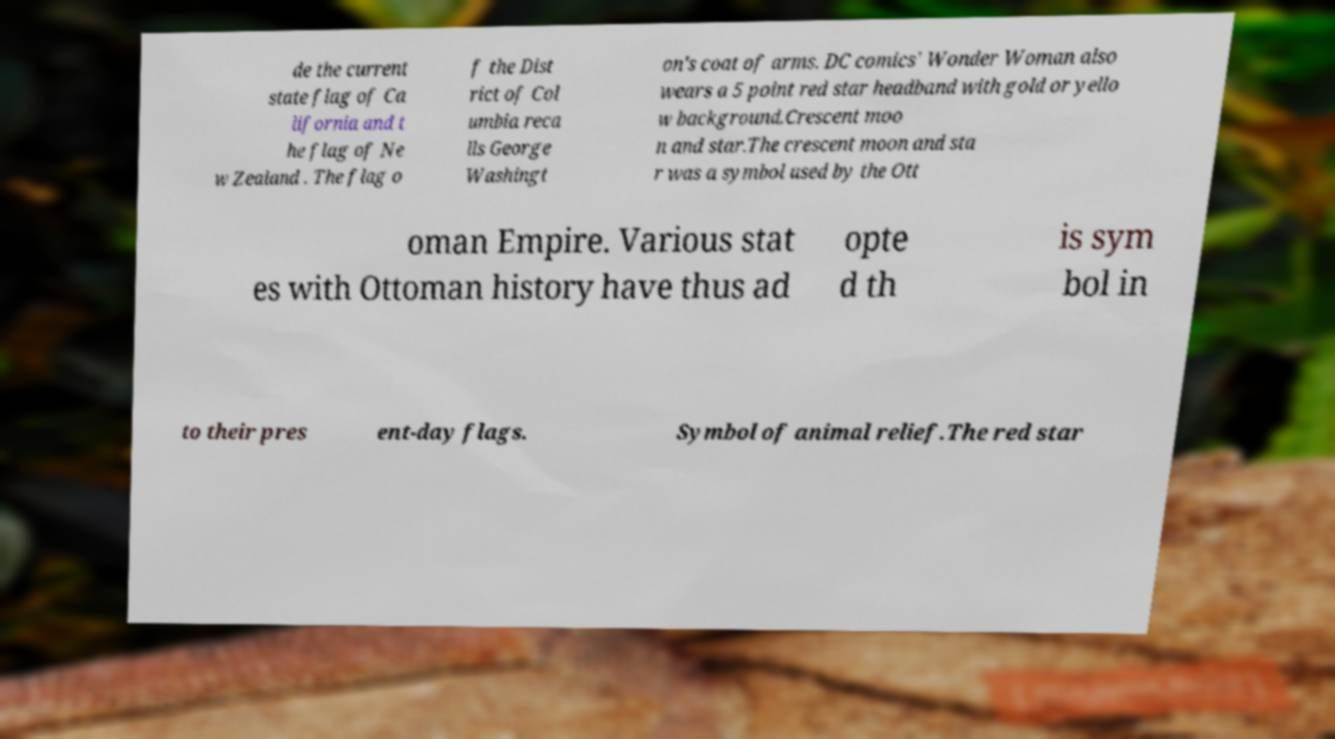Can you accurately transcribe the text from the provided image for me? de the current state flag of Ca lifornia and t he flag of Ne w Zealand . The flag o f the Dist rict of Col umbia reca lls George Washingt on's coat of arms. DC comics' Wonder Woman also wears a 5 point red star headband with gold or yello w background.Crescent moo n and star.The crescent moon and sta r was a symbol used by the Ott oman Empire. Various stat es with Ottoman history have thus ad opte d th is sym bol in to their pres ent-day flags. Symbol of animal relief.The red star 